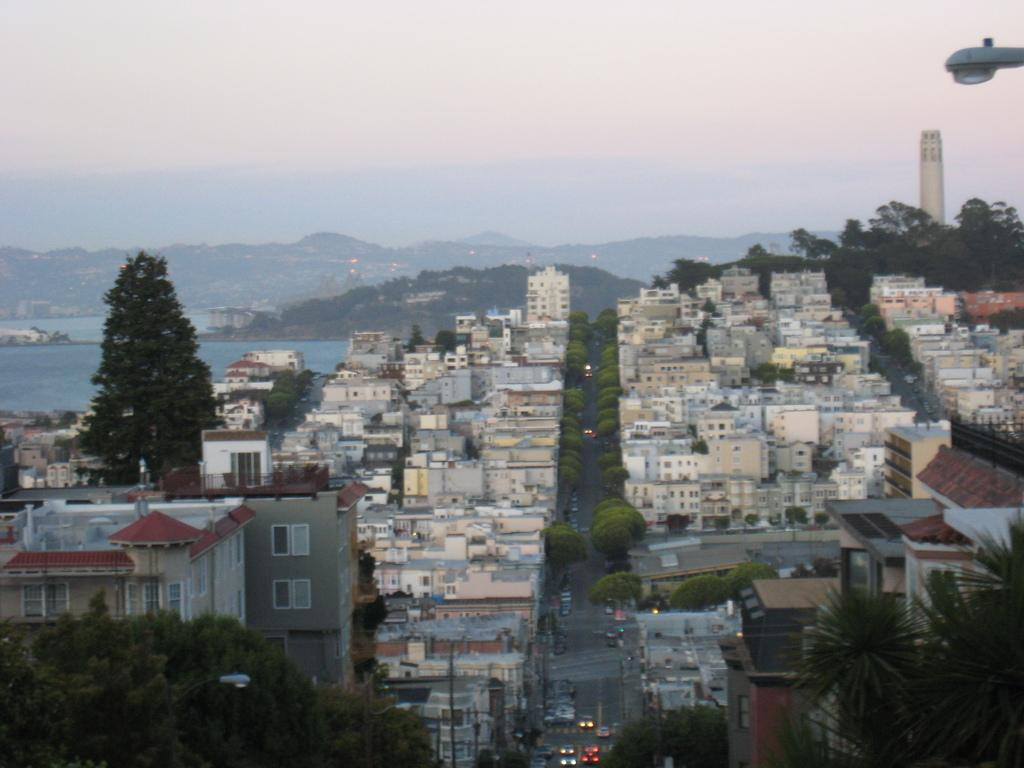What type of structures can be seen in the image? There are buildings in the image. What natural elements are present in the image? There are trees in the image. What artificial elements are present in the image? There are lights and vehicles on the road in the image. What can be seen in the background of the image? There is a tower, hills, and water visible in the background of the image. What type of meal is being served on the legs in the image? There is no meal or legs present in the image; it features buildings, trees, lights, vehicles, a tower, hills, and water. 